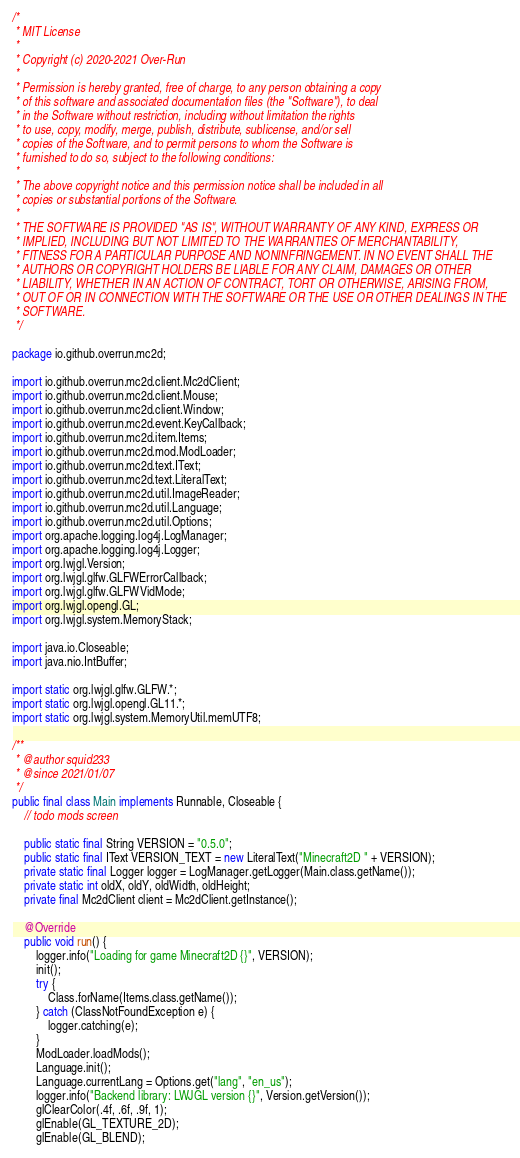<code> <loc_0><loc_0><loc_500><loc_500><_Java_>/*
 * MIT License
 *
 * Copyright (c) 2020-2021 Over-Run
 *
 * Permission is hereby granted, free of charge, to any person obtaining a copy
 * of this software and associated documentation files (the "Software"), to deal
 * in the Software without restriction, including without limitation the rights
 * to use, copy, modify, merge, publish, distribute, sublicense, and/or sell
 * copies of the Software, and to permit persons to whom the Software is
 * furnished to do so, subject to the following conditions:
 *
 * The above copyright notice and this permission notice shall be included in all
 * copies or substantial portions of the Software.
 *
 * THE SOFTWARE IS PROVIDED "AS IS", WITHOUT WARRANTY OF ANY KIND, EXPRESS OR
 * IMPLIED, INCLUDING BUT NOT LIMITED TO THE WARRANTIES OF MERCHANTABILITY,
 * FITNESS FOR A PARTICULAR PURPOSE AND NONINFRINGEMENT. IN NO EVENT SHALL THE
 * AUTHORS OR COPYRIGHT HOLDERS BE LIABLE FOR ANY CLAIM, DAMAGES OR OTHER
 * LIABILITY, WHETHER IN AN ACTION OF CONTRACT, TORT OR OTHERWISE, ARISING FROM,
 * OUT OF OR IN CONNECTION WITH THE SOFTWARE OR THE USE OR OTHER DEALINGS IN THE
 * SOFTWARE.
 */

package io.github.overrun.mc2d;

import io.github.overrun.mc2d.client.Mc2dClient;
import io.github.overrun.mc2d.client.Mouse;
import io.github.overrun.mc2d.client.Window;
import io.github.overrun.mc2d.event.KeyCallback;
import io.github.overrun.mc2d.item.Items;
import io.github.overrun.mc2d.mod.ModLoader;
import io.github.overrun.mc2d.text.IText;
import io.github.overrun.mc2d.text.LiteralText;
import io.github.overrun.mc2d.util.ImageReader;
import io.github.overrun.mc2d.util.Language;
import io.github.overrun.mc2d.util.Options;
import org.apache.logging.log4j.LogManager;
import org.apache.logging.log4j.Logger;
import org.lwjgl.Version;
import org.lwjgl.glfw.GLFWErrorCallback;
import org.lwjgl.glfw.GLFWVidMode;
import org.lwjgl.opengl.GL;
import org.lwjgl.system.MemoryStack;

import java.io.Closeable;
import java.nio.IntBuffer;

import static org.lwjgl.glfw.GLFW.*;
import static org.lwjgl.opengl.GL11.*;
import static org.lwjgl.system.MemoryUtil.memUTF8;

/**
 * @author squid233
 * @since 2021/01/07
 */
public final class Main implements Runnable, Closeable {
    // todo mods screen

    public static final String VERSION = "0.5.0";
    public static final IText VERSION_TEXT = new LiteralText("Minecraft2D " + VERSION);
    private static final Logger logger = LogManager.getLogger(Main.class.getName());
    private static int oldX, oldY, oldWidth, oldHeight;
    private final Mc2dClient client = Mc2dClient.getInstance();

    @Override
    public void run() {
        logger.info("Loading for game Minecraft2D {}", VERSION);
        init();
        try {
            Class.forName(Items.class.getName());
        } catch (ClassNotFoundException e) {
            logger.catching(e);
        }
        ModLoader.loadMods();
        Language.init();
        Language.currentLang = Options.get("lang", "en_us");
        logger.info("Backend library: LWJGL version {}", Version.getVersion());
        glClearColor(.4f, .6f, .9f, 1);
        glEnable(GL_TEXTURE_2D);
        glEnable(GL_BLEND);</code> 